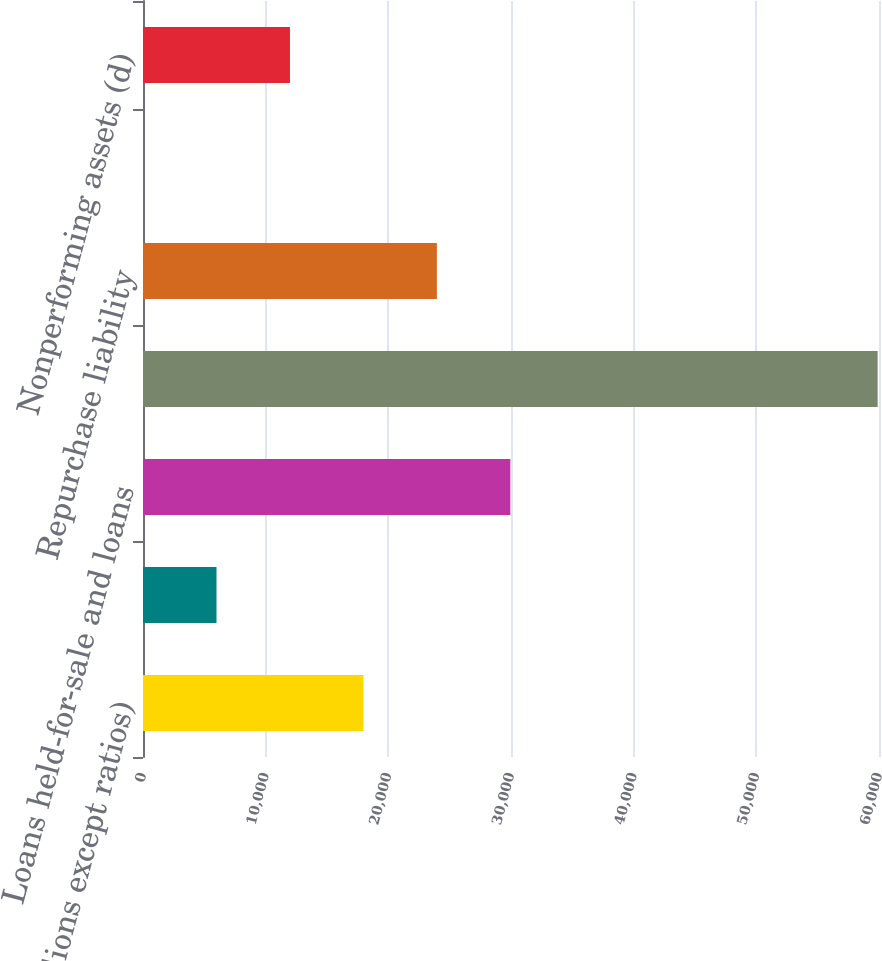Convert chart to OTSL. <chart><loc_0><loc_0><loc_500><loc_500><bar_chart><fcel>(in millions except ratios)<fcel>Prime mortgage including<fcel>Loans held-for-sale and loans<fcel>Average assets<fcel>Repurchase liability<fcel>30+ day delinquency rate (c)<fcel>Nonperforming assets (d)<nl><fcel>17969.5<fcel>5991.93<fcel>29947.1<fcel>59891<fcel>23958.3<fcel>3.15<fcel>11980.7<nl></chart> 